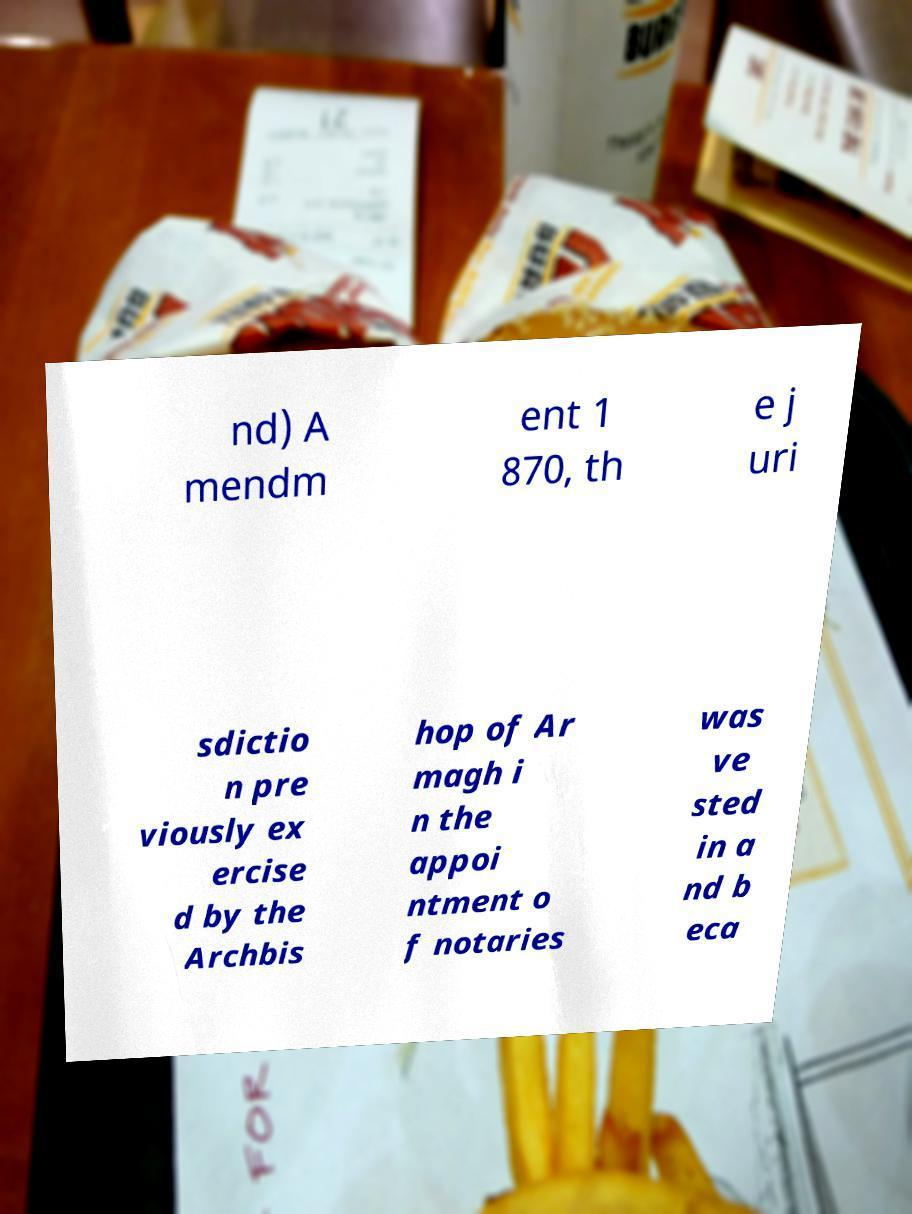What messages or text are displayed in this image? I need them in a readable, typed format. nd) A mendm ent 1 870, th e j uri sdictio n pre viously ex ercise d by the Archbis hop of Ar magh i n the appoi ntment o f notaries was ve sted in a nd b eca 